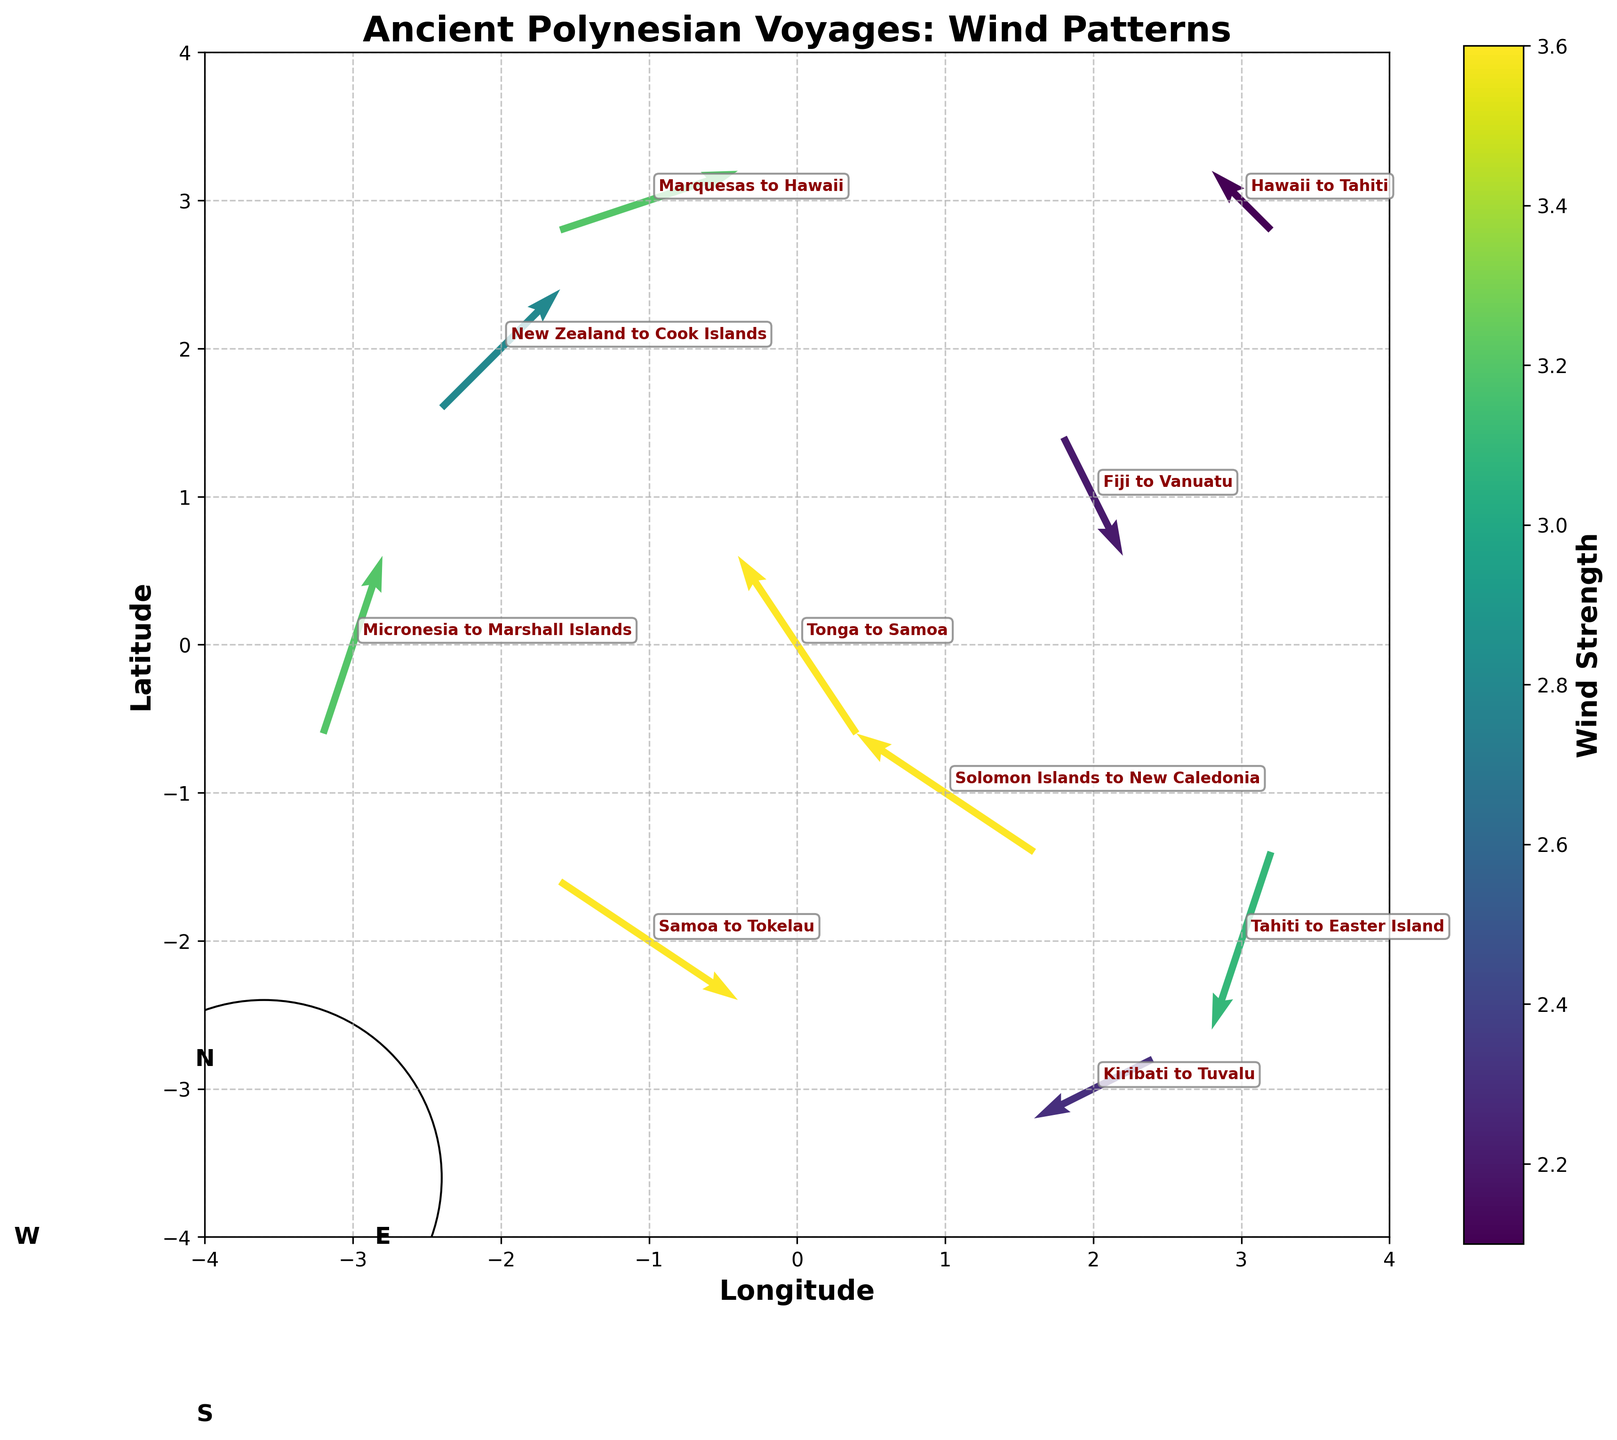What is the primary visual indication of wind strength in the plot? The wind strength is represented by the color of the arrows, with different shades indicating different strengths based on the colorbar labeled 'Wind Strength'.
Answer: Color of the arrows Which voyage has the highest wind strength and what is its value? The voyage from "Tonga to Samoa", "Solomon Islands to New Caledonia", and "Samoa to Tokelau" all have wind strengths of 3.6, the maximum on the colorbar.
Answer: 3.6 In which direction is the wind blowing for the voyage from "Marquesas to Hawaii"? The wind vector for this voyage originates from the point (-1,3) and points to (2,4), indicating a direction from the southwest to the northeast.
Answer: Southwest to northeast How many voyages have wind strengths greater than 3.0? By examining the color shades and referencing the colorbar, we can see there are 5 voyages with wind strengths greater than 3.0: "Tonga to Samoa", "Marquesas to Hawaii", "Tahiti to Easter Island", "Solomon Islands to New Caledonia", and "Samoa to Tokelau".
Answer: 5 Which voyages are represented with arrows pointing southward? Checking the quiver directions, the voyages from "Fiji to Vanuatu", "Tahiti to Easter Island", and "Kiribati to Tuvalu" have a southward component to their wind vectors.
Answer: "Fiji to Vanuatu", "Tahiti to Easter Island", and "Kiribati to Tuvalu" Are there any voyages with wind vectors that point directly horizontally or vertically? Examining the directional components of the wind vectors, none have purely horizontal (u,0) or vertical (0,v) components.
Answer: No What is the average wind strength of the voyages displayed in the plot? Sum the wind strengths (3.6 + 2.2 + 3.2 + 3.1 + 2.8 + 3.6 + 3.2 + 2.3 + 3.6 + 2.1) to get 29.7. Divide by the number of voyages, 10, to get the average wind strength which is 29.7 / 10 = 2.97.
Answer: 2.97 Which voyage has the most northerly starting point? "Marquesas to Hawaii" starts at the highest latitude (y=3).
Answer: "Marquesas to Hawaii" How many voyages involve eastward wind? Checking the u component of the vectors (positive u values), 3 voyages have an eastward wind: "Tonga to Samoa", "New Zealand to Cook Islands", and "Marquesas to Hawaii".
Answer: 3 